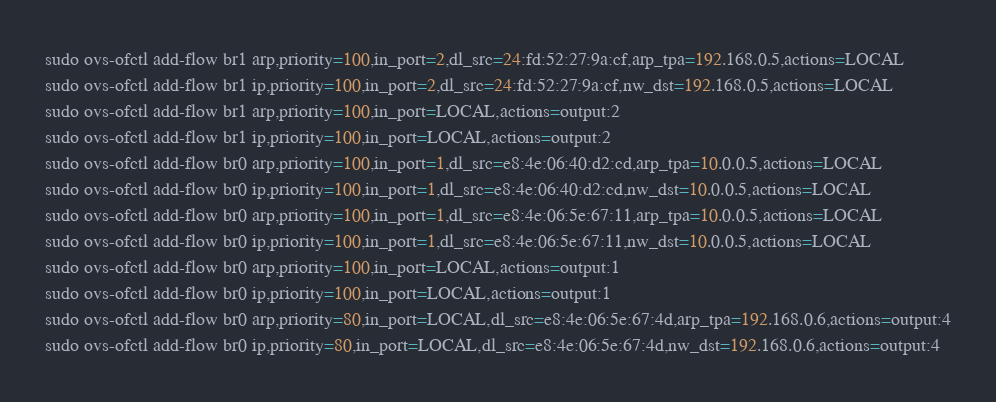Convert code to text. <code><loc_0><loc_0><loc_500><loc_500><_Bash_>sudo ovs-ofctl add-flow br1 arp,priority=100,in_port=2,dl_src=24:fd:52:27:9a:cf,arp_tpa=192.168.0.5,actions=LOCAL
sudo ovs-ofctl add-flow br1 ip,priority=100,in_port=2,dl_src=24:fd:52:27:9a:cf,nw_dst=192.168.0.5,actions=LOCAL
sudo ovs-ofctl add-flow br1 arp,priority=100,in_port=LOCAL,actions=output:2
sudo ovs-ofctl add-flow br1 ip,priority=100,in_port=LOCAL,actions=output:2
sudo ovs-ofctl add-flow br0 arp,priority=100,in_port=1,dl_src=e8:4e:06:40:d2:cd,arp_tpa=10.0.0.5,actions=LOCAL
sudo ovs-ofctl add-flow br0 ip,priority=100,in_port=1,dl_src=e8:4e:06:40:d2:cd,nw_dst=10.0.0.5,actions=LOCAL
sudo ovs-ofctl add-flow br0 arp,priority=100,in_port=1,dl_src=e8:4e:06:5e:67:11,arp_tpa=10.0.0.5,actions=LOCAL
sudo ovs-ofctl add-flow br0 ip,priority=100,in_port=1,dl_src=e8:4e:06:5e:67:11,nw_dst=10.0.0.5,actions=LOCAL
sudo ovs-ofctl add-flow br0 arp,priority=100,in_port=LOCAL,actions=output:1
sudo ovs-ofctl add-flow br0 ip,priority=100,in_port=LOCAL,actions=output:1
sudo ovs-ofctl add-flow br0 arp,priority=80,in_port=LOCAL,dl_src=e8:4e:06:5e:67:4d,arp_tpa=192.168.0.6,actions=output:4
sudo ovs-ofctl add-flow br0 ip,priority=80,in_port=LOCAL,dl_src=e8:4e:06:5e:67:4d,nw_dst=192.168.0.6,actions=output:4</code> 